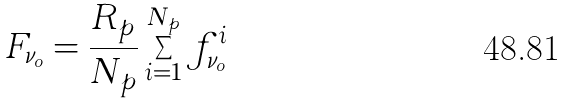Convert formula to latex. <formula><loc_0><loc_0><loc_500><loc_500>F _ { \nu _ { o } } = \frac { R _ { p } } { N _ { p } } \sum _ { i = 1 } ^ { N _ { p } } f _ { \nu _ { o } } ^ { i }</formula> 